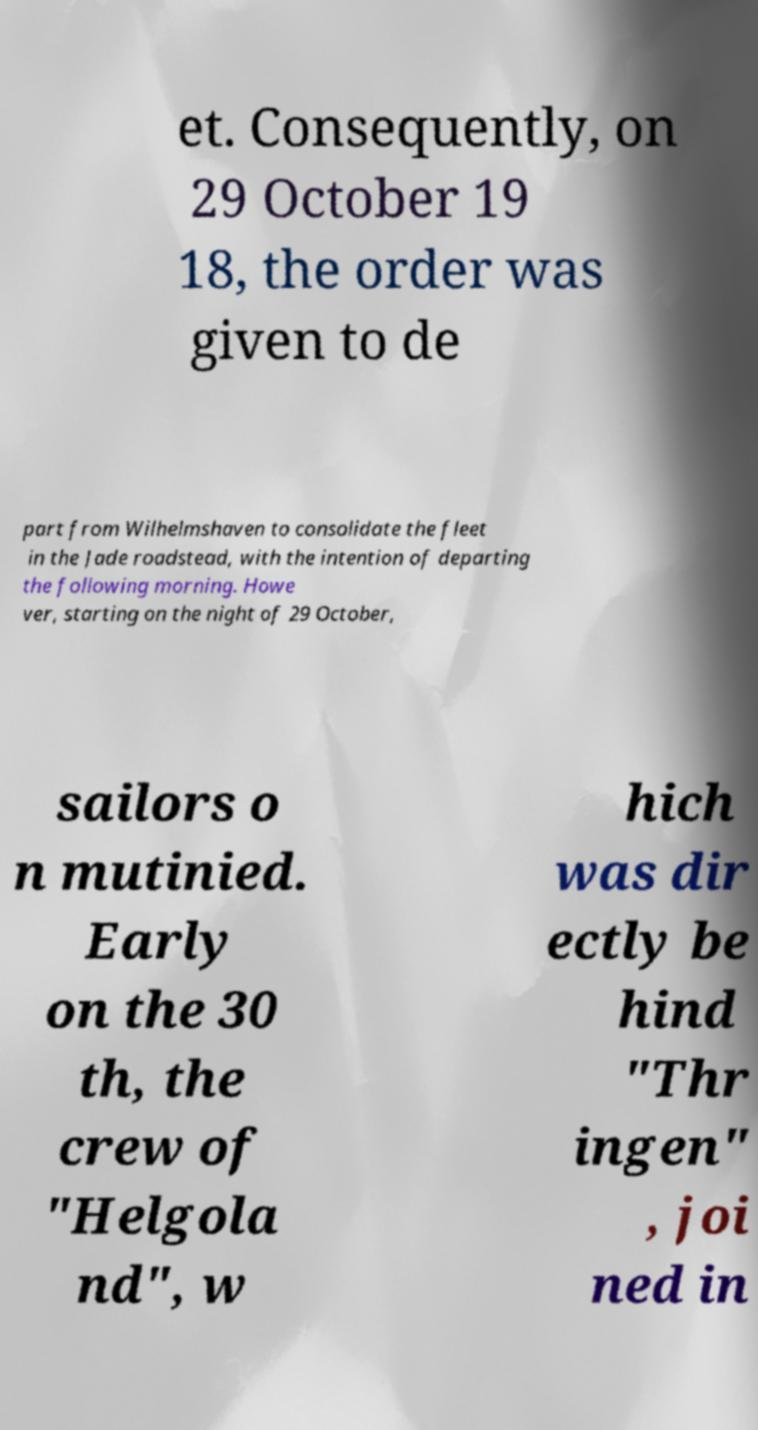Could you extract and type out the text from this image? et. Consequently, on 29 October 19 18, the order was given to de part from Wilhelmshaven to consolidate the fleet in the Jade roadstead, with the intention of departing the following morning. Howe ver, starting on the night of 29 October, sailors o n mutinied. Early on the 30 th, the crew of "Helgola nd", w hich was dir ectly be hind "Thr ingen" , joi ned in 